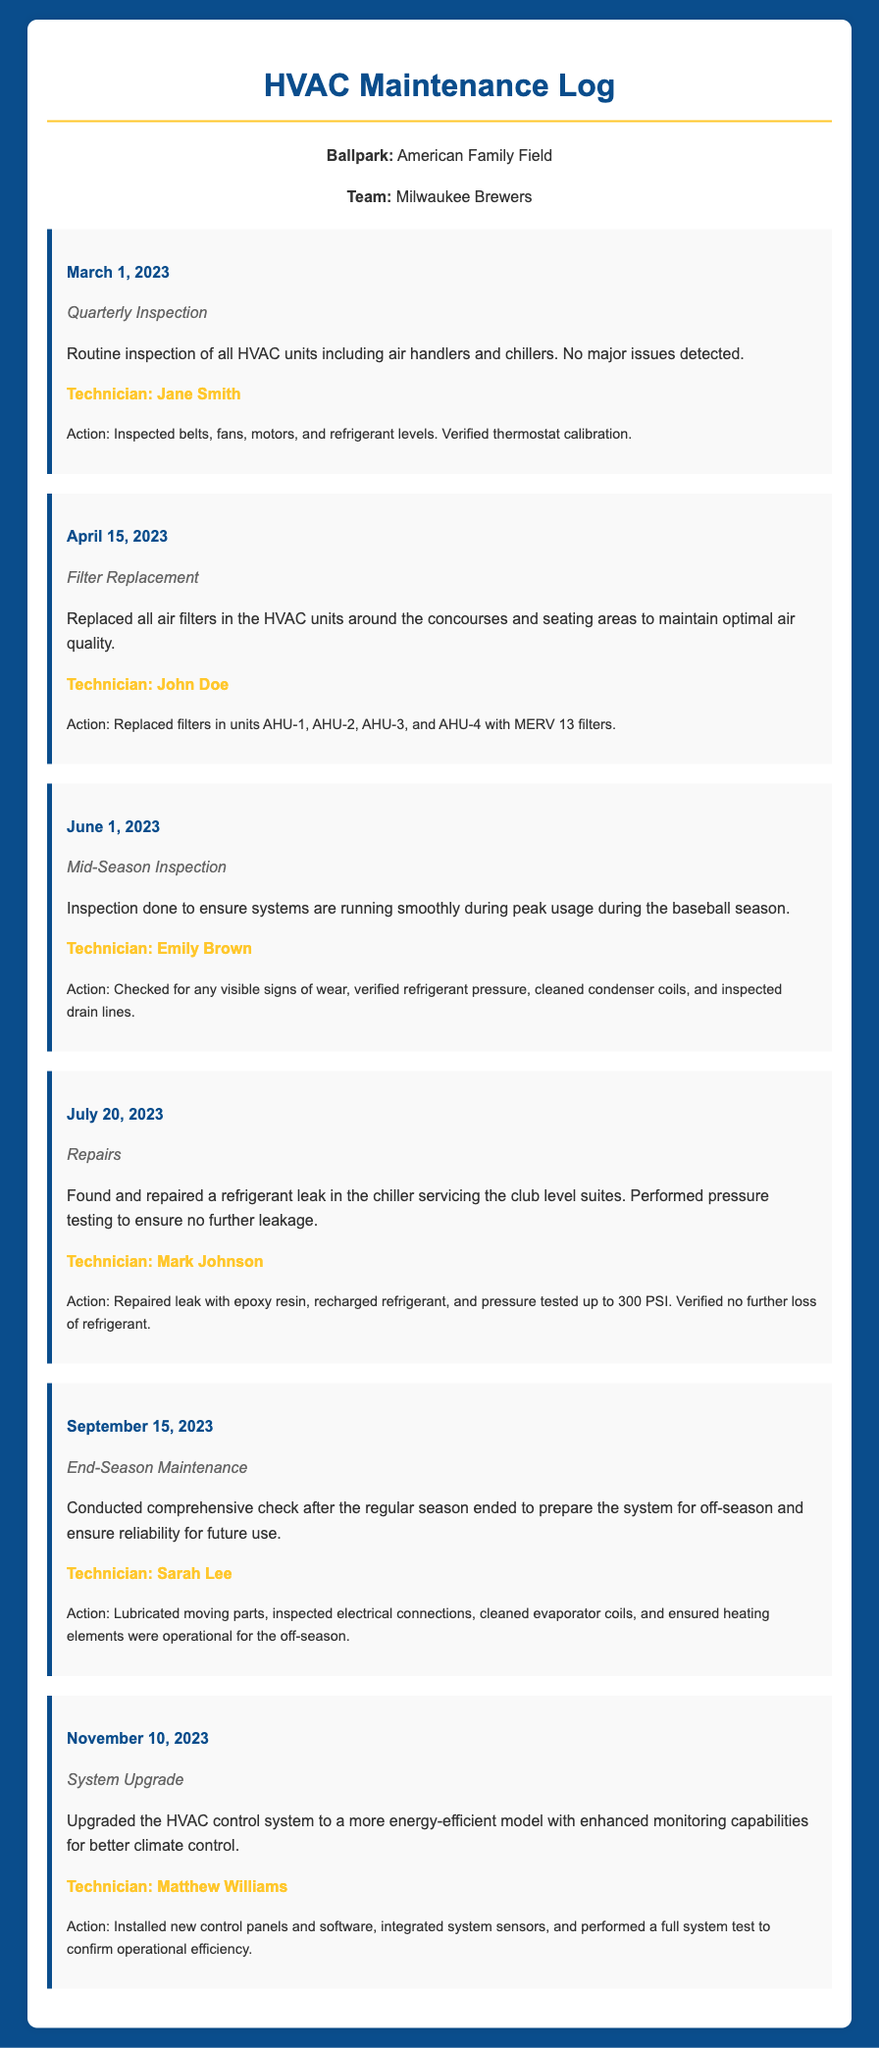What date was the quarterly inspection conducted? The date of the quarterly inspection is found in the log entry dated March 1, 2023.
Answer: March 1, 2023 Who performed the filter replacement? The technician who performed the filter replacement is mentioned in the log entry for April 15, 2023.
Answer: John Doe What type of maintenance was done on July 20, 2023? The log entry for July 20, 2023 specifies what type of maintenance was conducted.
Answer: Repairs What was inspected during the mid-season inspection? The log entry for June 1, 2023 details what was checked during the mid-season inspection.
Answer: Signs of wear, refrigerant pressure, condenser coils, drain lines What was the outcome of the system upgrade on November 10, 2023? The log entry on November 10, 2023 highlights the result of the system upgrade performed by a technician.
Answer: Enhanced monitoring capabilities How many air filters were replaced during the maintenance? The log entry from April 15, 2023 indicates which units had their filters replaced, suggesting the total count.
Answer: All air filters in units AHU-1, AHU-2, AHU-3, and AHU-4 What action was taken during the end-season maintenance? The log entry for September 15, 2023 describes what actions were performed during the end-season maintenance.
Answer: Lubricated moving parts, inspected electrical connections, cleaned evaporator coils, ensured heating elements operational Who conducted the mid-season inspection? The technician's name who conducted the mid-season inspection can be found in the log entry for June 1, 2023.
Answer: Emily Brown 